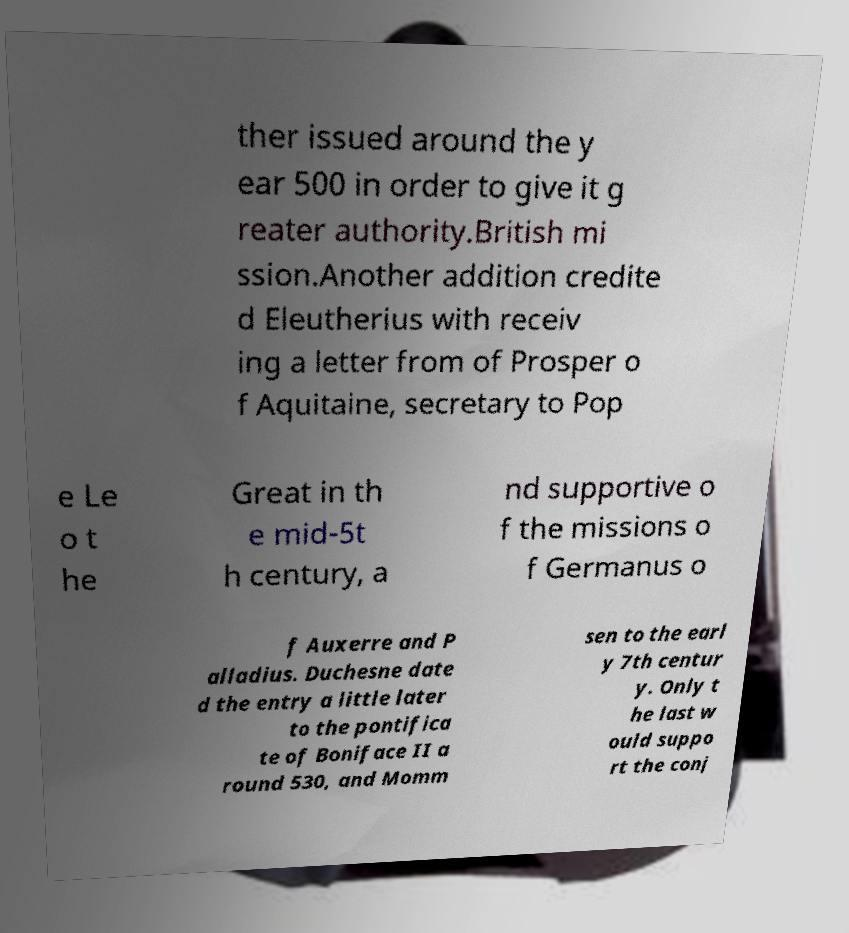Can you accurately transcribe the text from the provided image for me? ther issued around the y ear 500 in order to give it g reater authority.British mi ssion.Another addition credite d Eleutherius with receiv ing a letter from of Prosper o f Aquitaine, secretary to Pop e Le o t he Great in th e mid-5t h century, a nd supportive o f the missions o f Germanus o f Auxerre and P alladius. Duchesne date d the entry a little later to the pontifica te of Boniface II a round 530, and Momm sen to the earl y 7th centur y. Only t he last w ould suppo rt the conj 